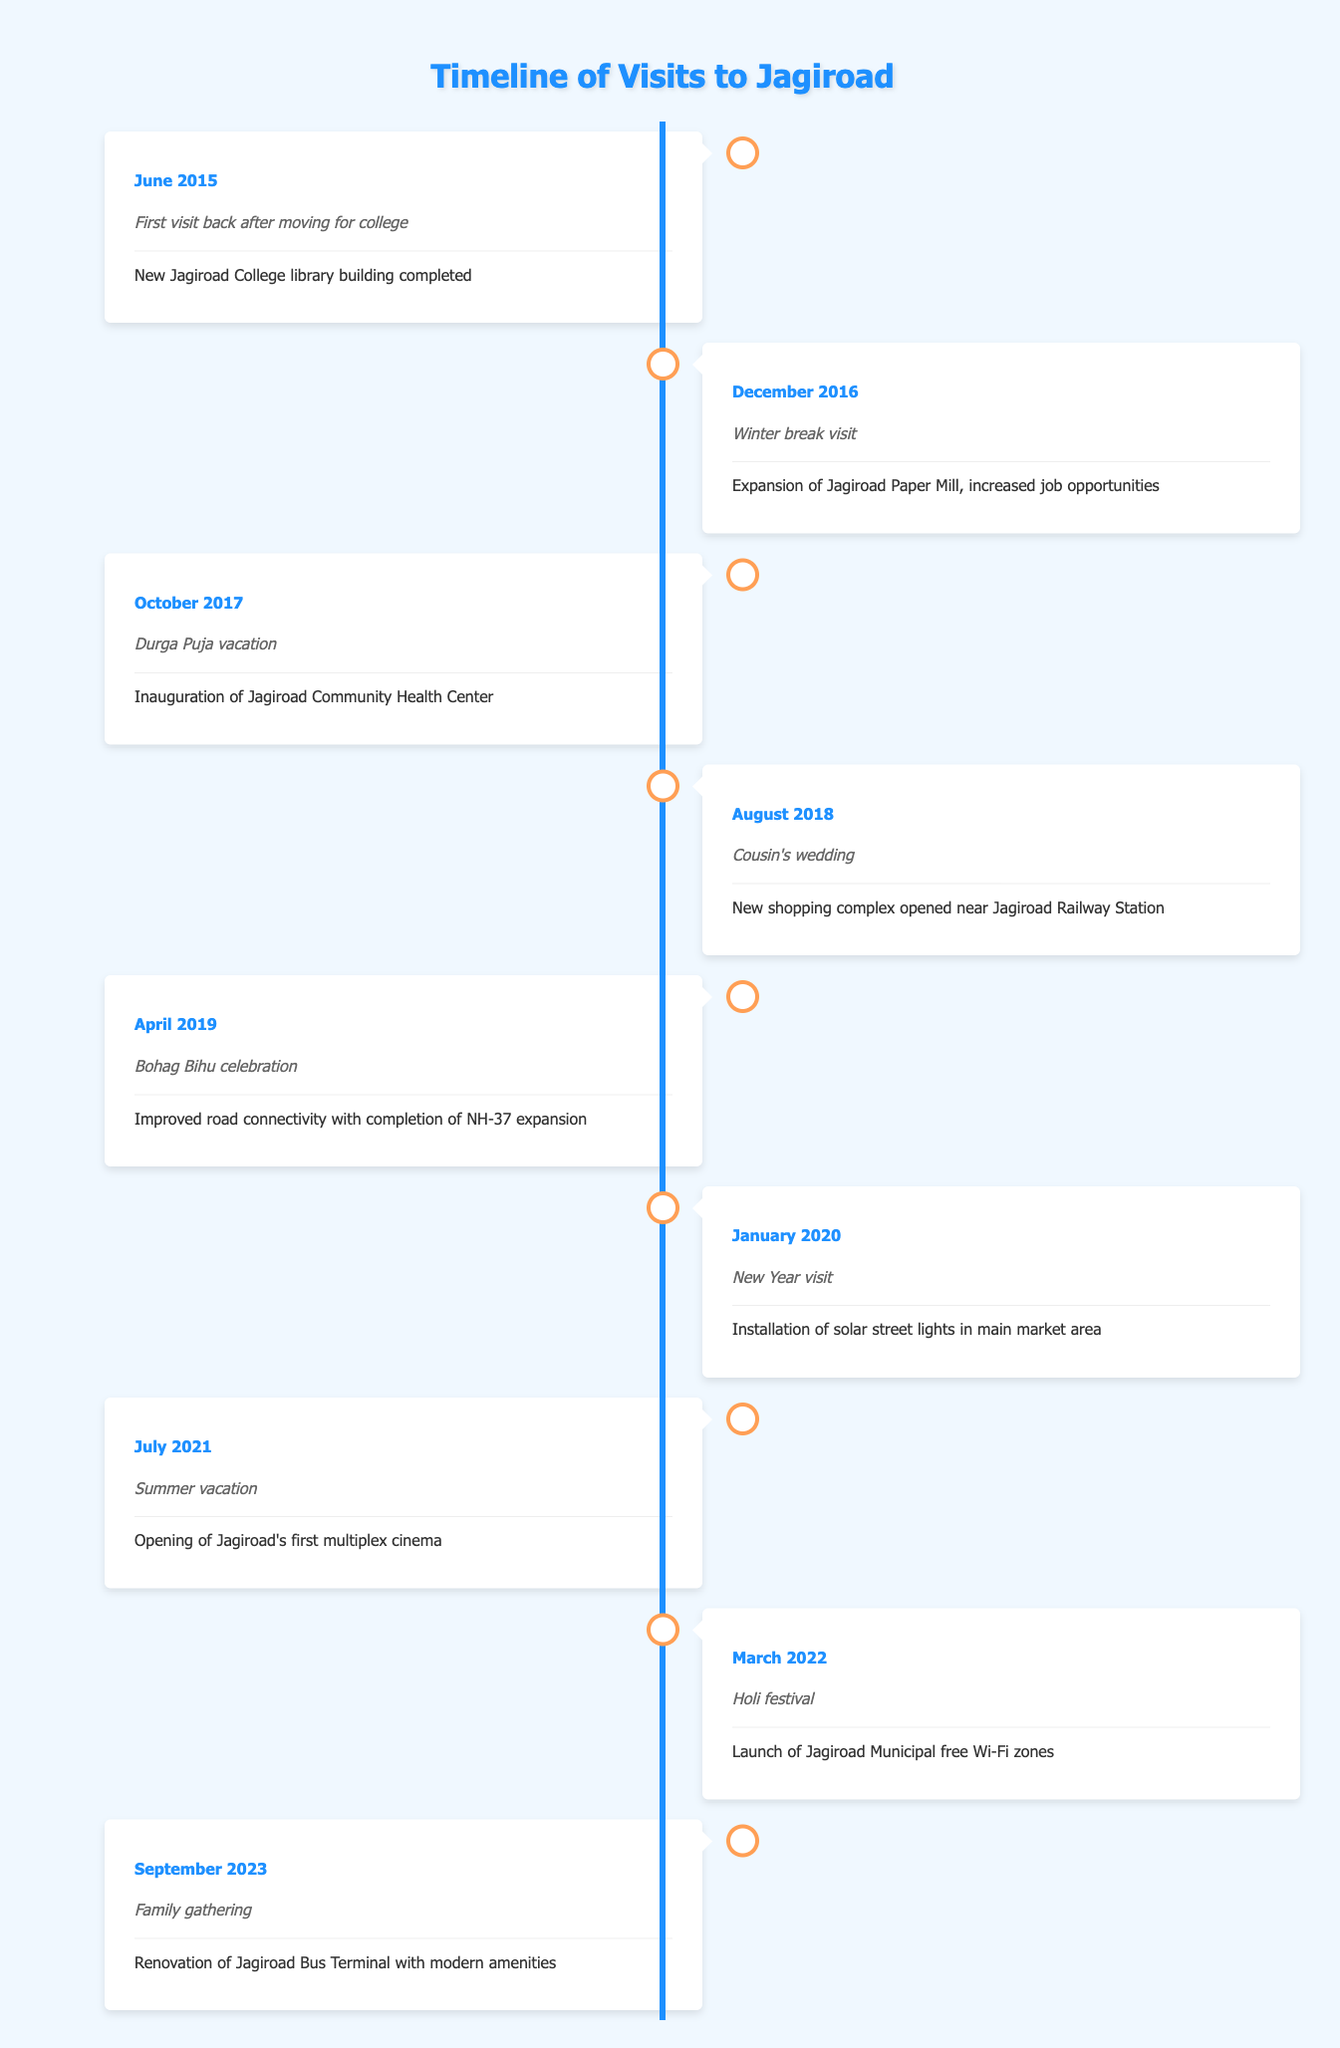What event took place in June 2015? The table specifies that the event in June 2015 was the "First visit back after moving for college."
Answer: First visit back after moving for college How many significant events were recorded in the year 2021? Looking at the table, there is only one event recorded for the year 2021, which is the "Opening of Jagiroad's first multiplex cinema" in July.
Answer: 1 Was there an event related to health in October 2017? Yes, the table shows the inauguration of the Jagiroad Community Health Center, which is related to health.
Answer: Yes What is the most recent observation listed in the timeline? The most recent observation is from September 2023, which mentions the "Renovation of Jagiroad Bus Terminal with modern amenities."
Answer: Renovation of Jagiroad Bus Terminal with modern amenities In which year did the shopping complex open near Jagiroad Railway Station? According to the table, the new shopping complex opened in August 2018 during a visit for a cousin's wedding.
Answer: 2018 How many visits were made back to Jagiroad between 2015 and 2023? The timeline lists a total of 9 visits back to Jagiroad from 2015 to 2023.
Answer: 9 Was there any development related to technology in March 2022? Yes, the launch of Jagiroad Municipal free Wi-Fi zones in March 2022 indicates a technology-related development.
Answer: Yes Which year saw the expansion of Jagiroad Paper Mill? The expansion of Jagiroad Paper Mill occurred in December 2016.
Answer: 2016 How does the frequency of visits to Jagiroad change from 2015 to 2023? Upon reviewing the timeline, it's observed that there is one visit each year from 2015 to 2023, with no frequency increase or decrease; the visits remain consistent as there are no skipped years.
Answer: Consistent frequency of 1 visit per year 